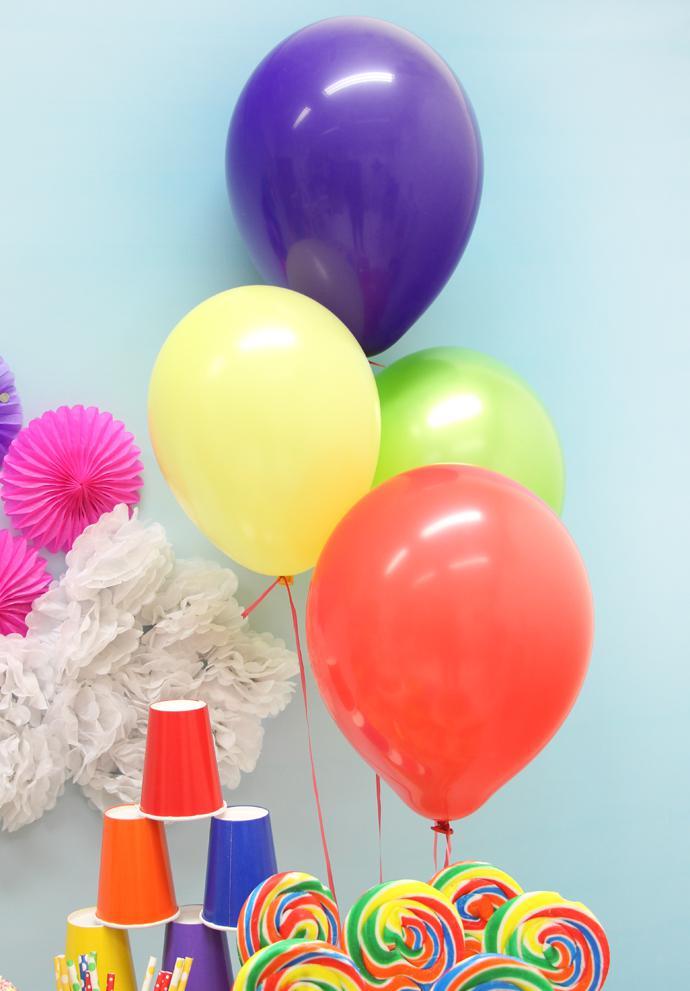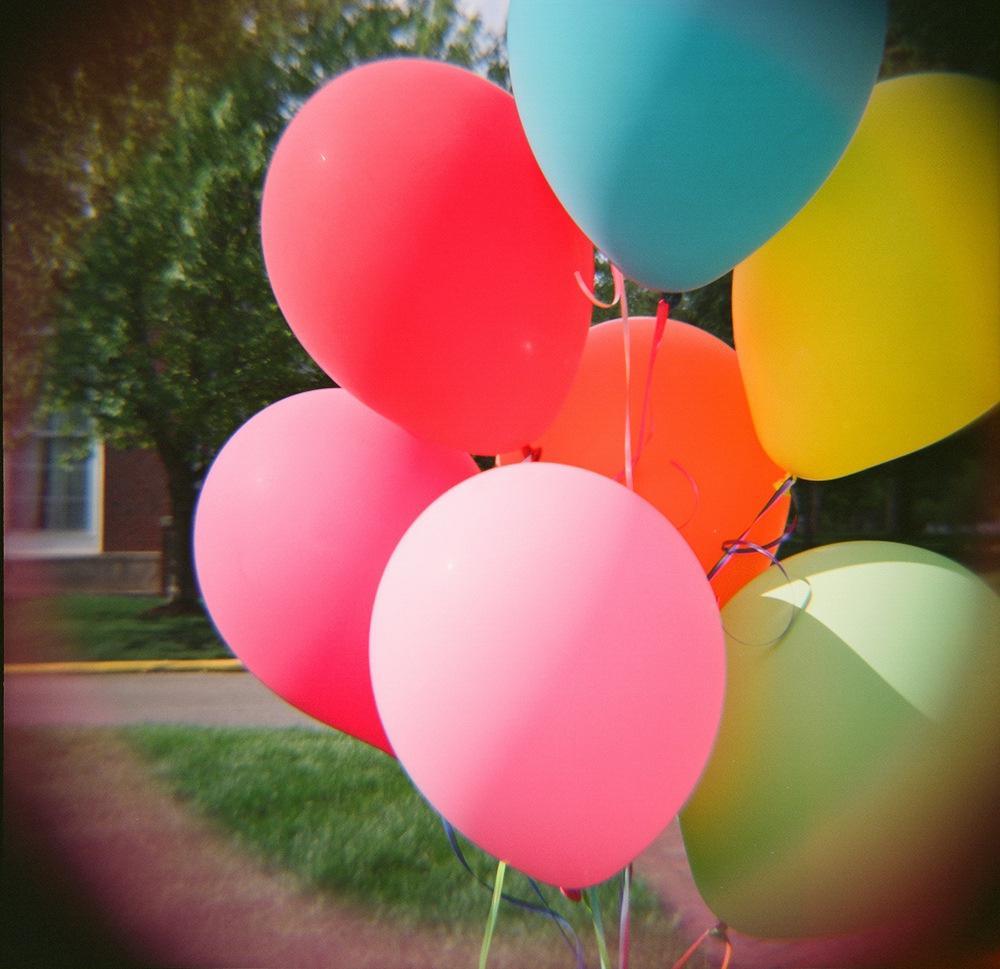The first image is the image on the left, the second image is the image on the right. For the images shown, is this caption "In one image there is a person holding at least 1 balloon." true? Answer yes or no. No. The first image is the image on the left, the second image is the image on the right. Assess this claim about the two images: "One of the images shows someone holding at least one balloon and the other image shows a bunch of balloons in different colors.". Correct or not? Answer yes or no. No. 